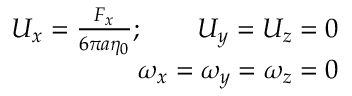Convert formula to latex. <formula><loc_0><loc_0><loc_500><loc_500>\begin{array} { r } { U _ { x } = \frac { F _ { x } } { 6 \pi a \eta _ { 0 } } ; \quad U _ { y } = U _ { z } = 0 } \\ { \omega _ { x } = \omega _ { y } = \omega _ { z } = 0 } \end{array}</formula> 